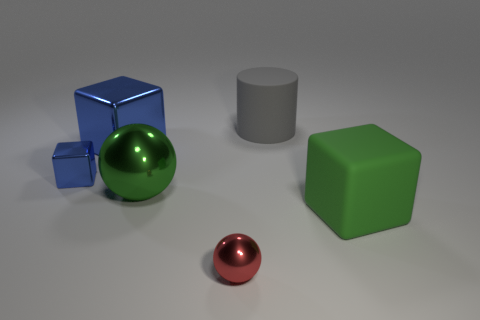Add 4 large blue objects. How many objects exist? 10 Subtract all balls. How many objects are left? 4 Subtract 0 gray balls. How many objects are left? 6 Subtract all small green rubber things. Subtract all large gray cylinders. How many objects are left? 5 Add 1 metallic cubes. How many metallic cubes are left? 3 Add 2 small shiny blocks. How many small shiny blocks exist? 3 